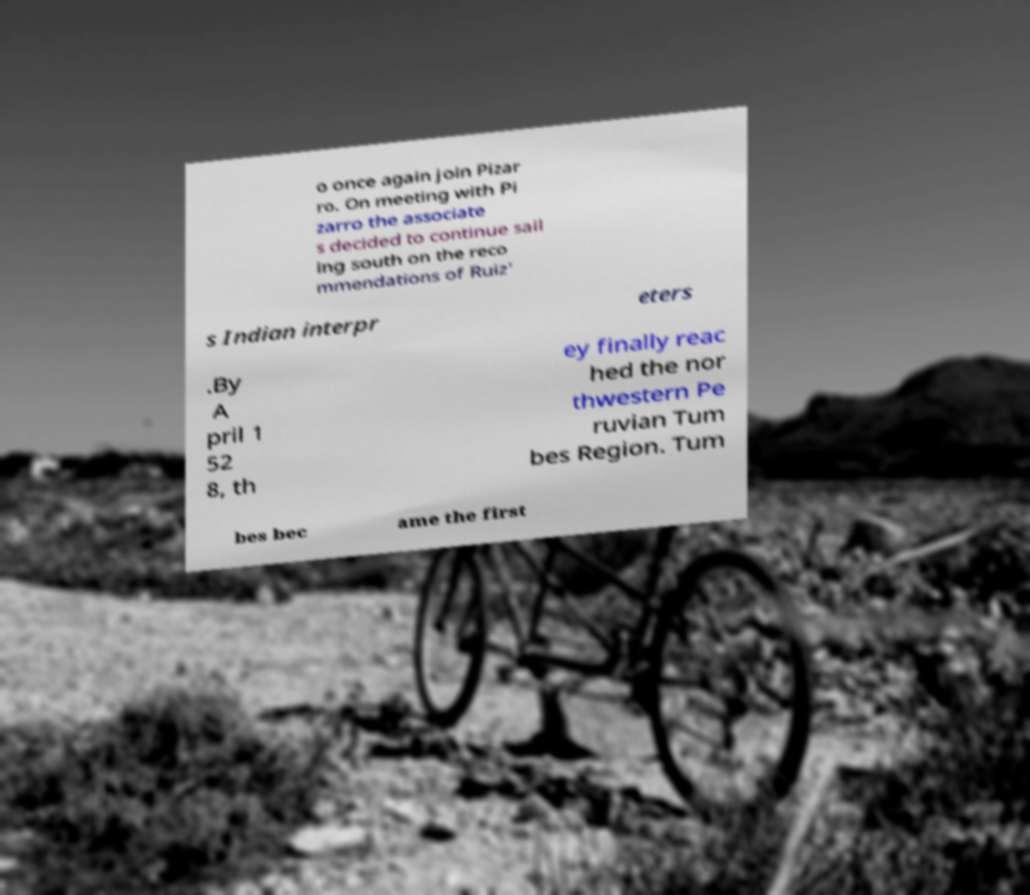There's text embedded in this image that I need extracted. Can you transcribe it verbatim? o once again join Pizar ro. On meeting with Pi zarro the associate s decided to continue sail ing south on the reco mmendations of Ruiz' s Indian interpr eters .By A pril 1 52 8, th ey finally reac hed the nor thwestern Pe ruvian Tum bes Region. Tum bes bec ame the first 